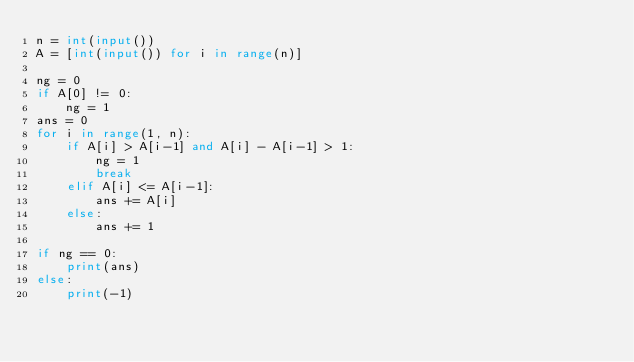Convert code to text. <code><loc_0><loc_0><loc_500><loc_500><_Python_>n = int(input())
A = [int(input()) for i in range(n)]

ng = 0
if A[0] != 0:
    ng = 1
ans = 0
for i in range(1, n):
    if A[i] > A[i-1] and A[i] - A[i-1] > 1:
        ng = 1
        break
    elif A[i] <= A[i-1]:
        ans += A[i]
    else:
        ans += 1

if ng == 0:
    print(ans)
else:
    print(-1)</code> 